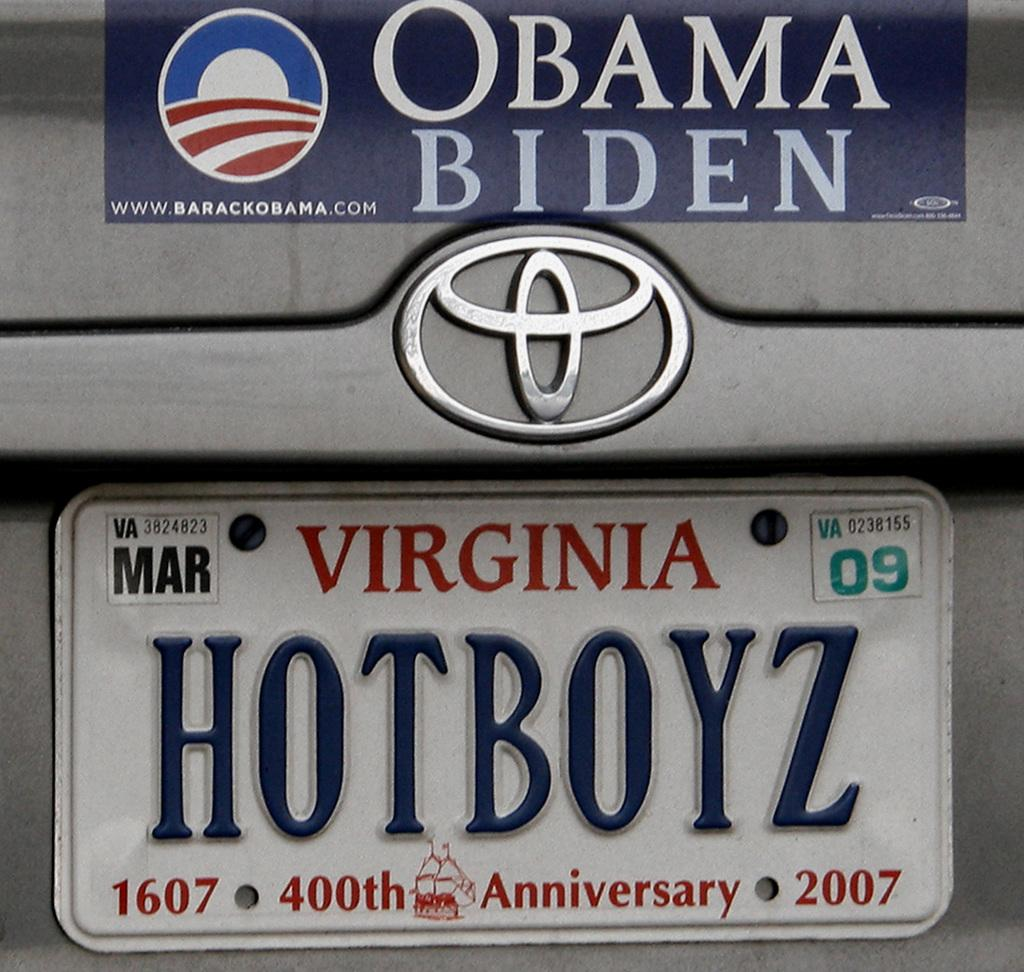Provide a one-sentence caption for the provided image. Virginia car plate on the bottom of Obama Biden sticker. 